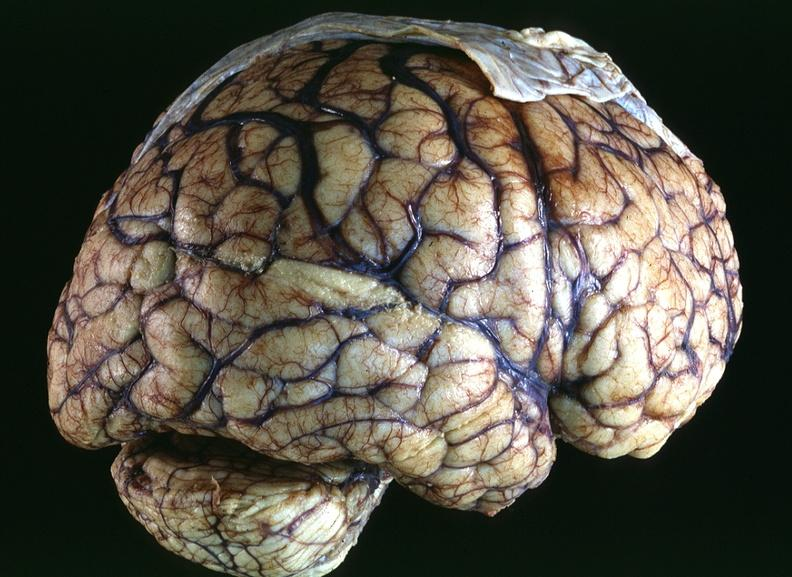what does this image show?
Answer the question using a single word or phrase. Toxoplasmosis 